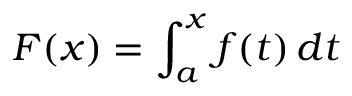<formula> <loc_0><loc_0><loc_500><loc_500>F ( x ) = \int _ { a } ^ { x } f ( t ) \, d t</formula> 